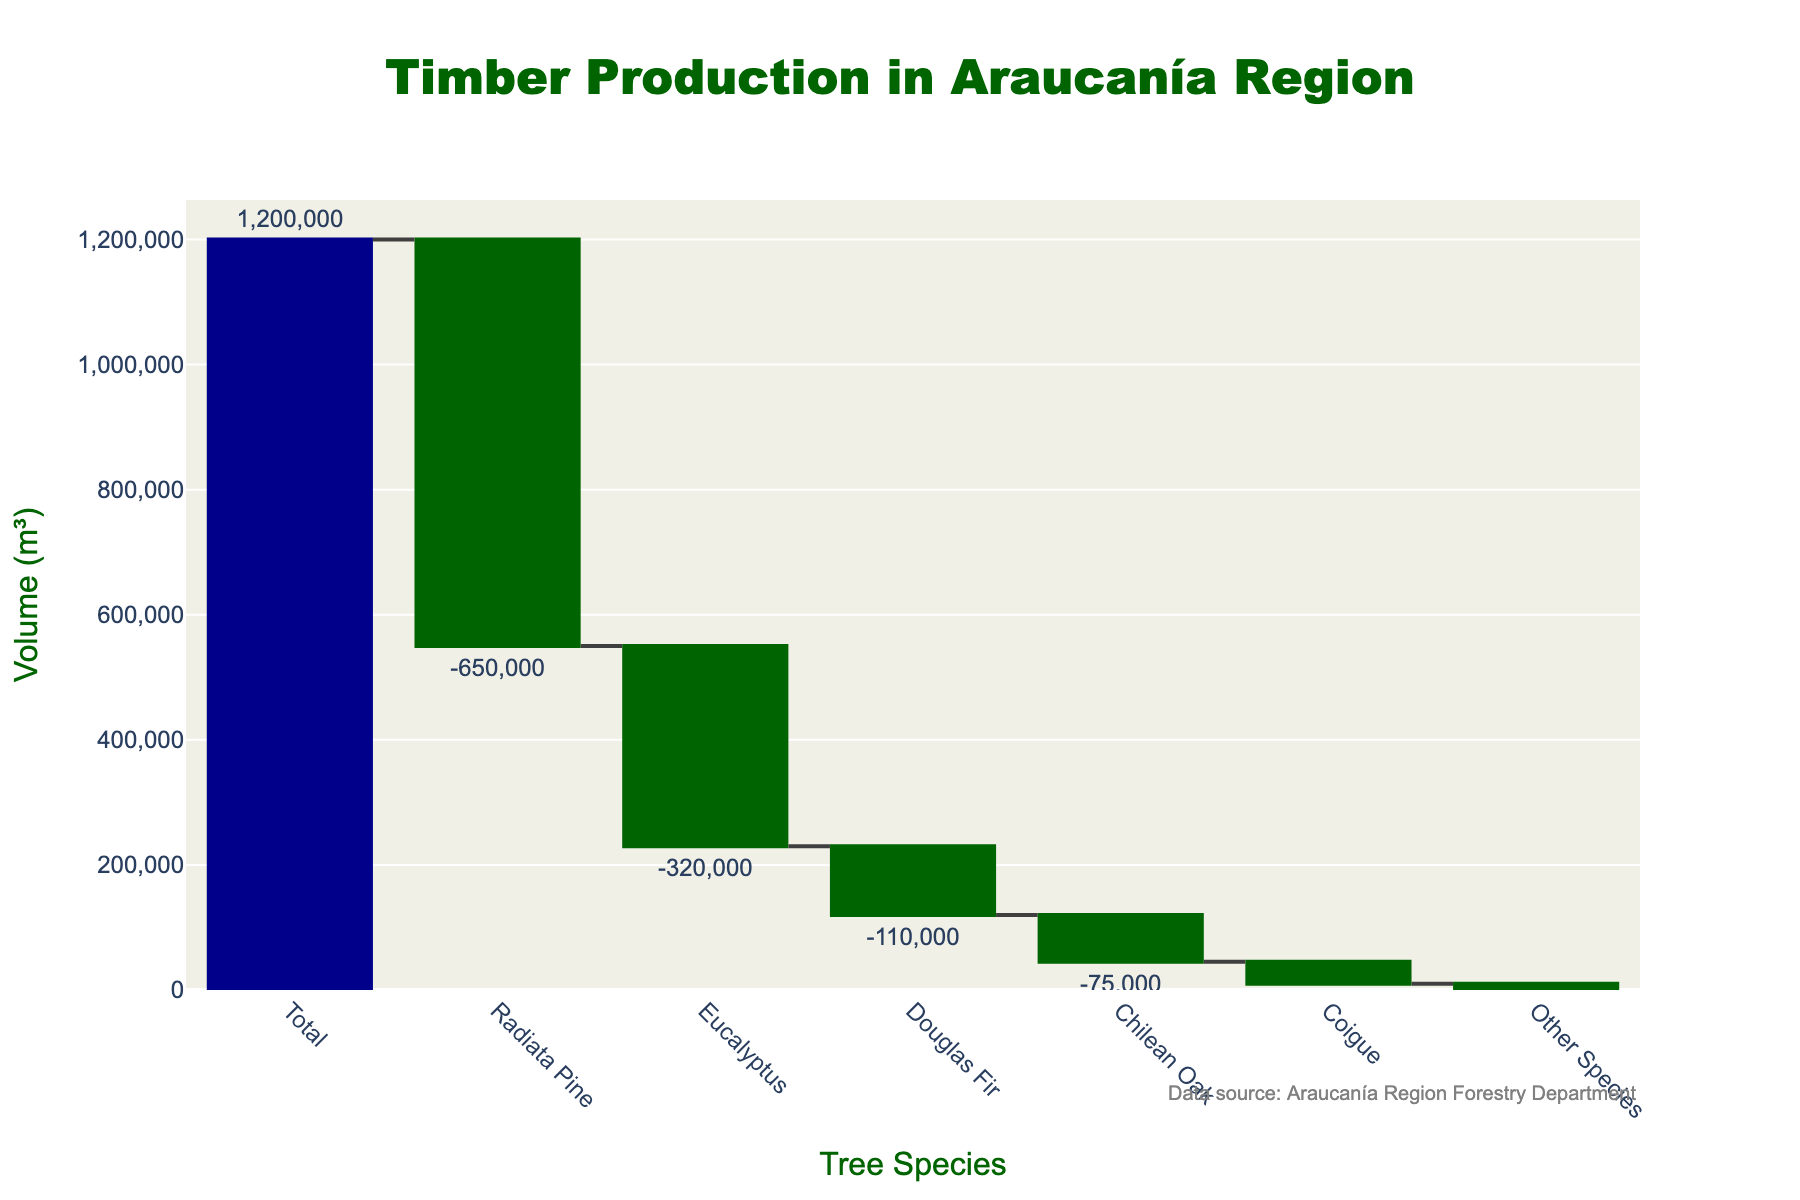What's the title of the figure? The title of the figure is prominently displayed at the top and is written in large, bold letters.
Answer: Timber Production in Araucanía Region What tree species contributes the most to the total timber production? To determine which tree species contributes the most, look for the species with the largest negative volume bar.
Answer: Radiata Pine How much more timber does Radiata Pine contribute compared to Eucalyptus? Subtract the volume of Eucalyptus from the volume of Radiata Pine (-650,000 - -320,000 = -330,000).
Answer: 330,000 m³ What's the combined timber volume contributed by Douglas Fir, Chilean Oak, Coigue, and Other Species? Sum the volumes of all these species: -110,000 + -75,000 + -35,000 + -10,000 = -230,000.
Answer: -230,000 m³ Which tree species has the least contribution to timber production? Look for the species with the smallest negative volume bar.
Answer: Other Species What's the volume difference between the Chilean Oak and Coigue? Subtract the volume of Coigue from the volume of Chilean Oak (-75,000 - -35,000 = -40,000).
Answer: 40,000 m³ Which species' contribution, when combined with Coigue, will result in a cumulative volume of -45,000 m³? Look for a species whose volume added with the volume of Coigue results in -45,000. Since Coigue is -35,000, we need another species contributing -10,000.
Answer: Other Species How does the total contribution of Eucalyptus compare to Radiata Pine in terms of volume? Compare the two volumes directly. Eucalyptus has a negative volume of -320,000, while Radiata Pine has -650,000.
Answer: Radiata Pine has a greater negative volume What is the cumulative timber volume after Douglas Fir? The cumulative sum is the addition of volumes up until Douglas Fir: 1,200,000 - 650,000 - 320,000 - 110,000 = 120,000.
Answer: 120,000 m³ 